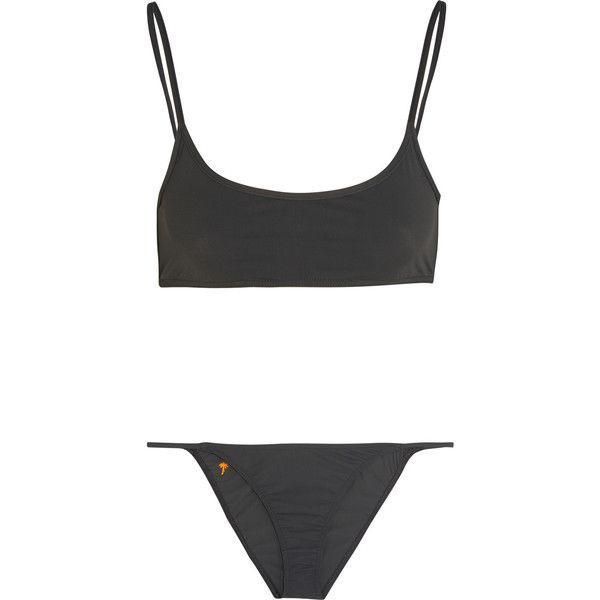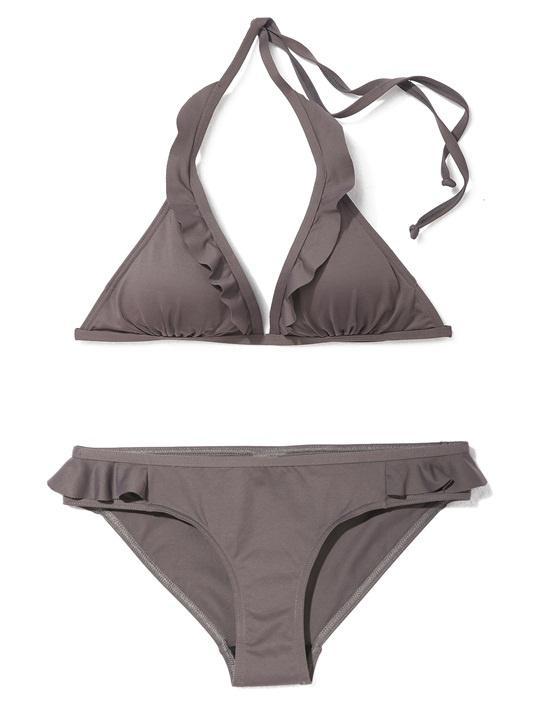The first image is the image on the left, the second image is the image on the right. Analyze the images presented: Is the assertion "One bikini has a tieable strap." valid? Answer yes or no. Yes. 